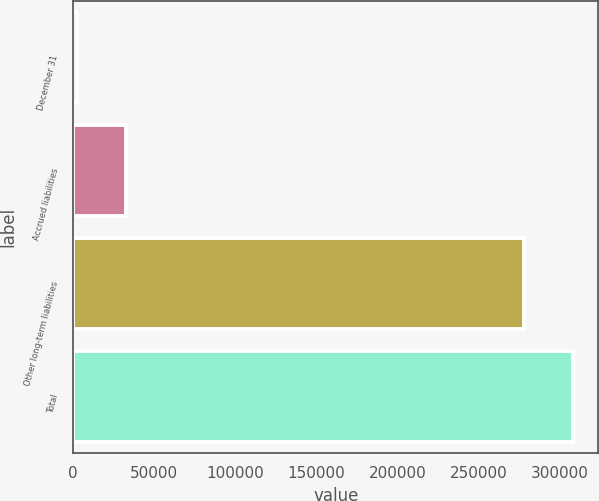Convert chart to OTSL. <chart><loc_0><loc_0><loc_500><loc_500><bar_chart><fcel>December 31<fcel>Accrued liabilities<fcel>Other long-term liabilities<fcel>Total<nl><fcel>2010<fcel>32439<fcel>277963<fcel>308392<nl></chart> 